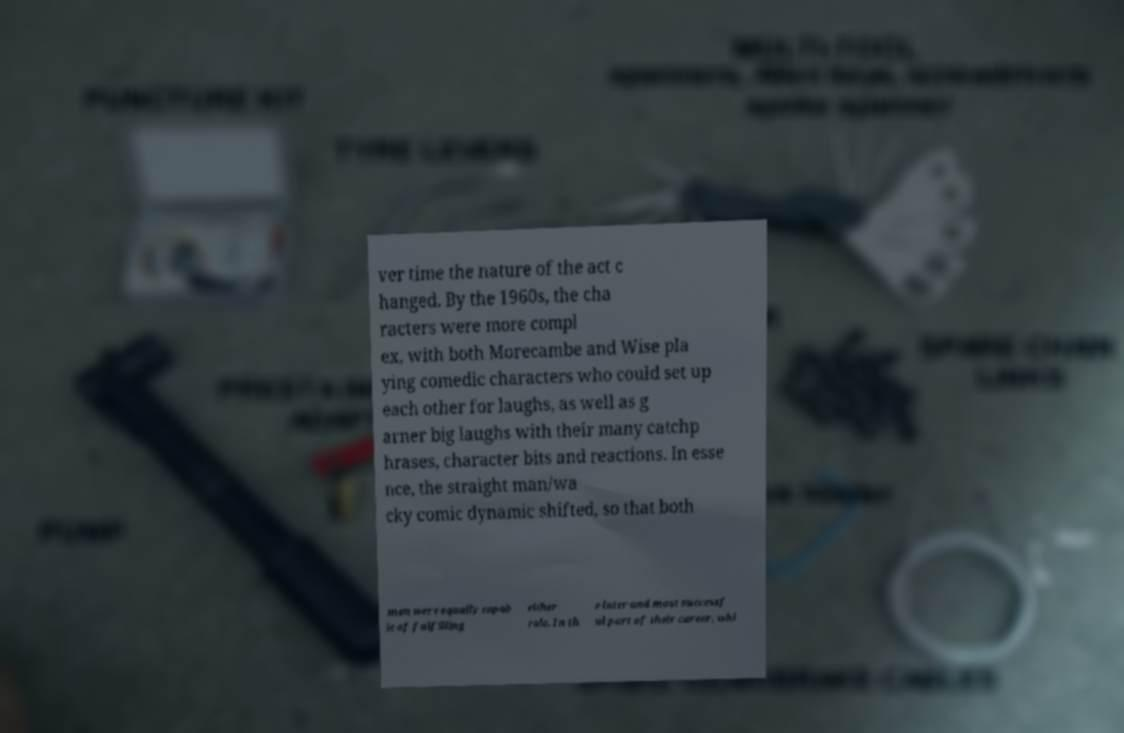Please identify and transcribe the text found in this image. ver time the nature of the act c hanged. By the 1960s, the cha racters were more compl ex, with both Morecambe and Wise pla ying comedic characters who could set up each other for laughs, as well as g arner big laughs with their many catchp hrases, character bits and reactions. In esse nce, the straight man/wa cky comic dynamic shifted, so that both men were equally capab le of fulfilling either role. In th e later and most successf ul part of their career, whi 